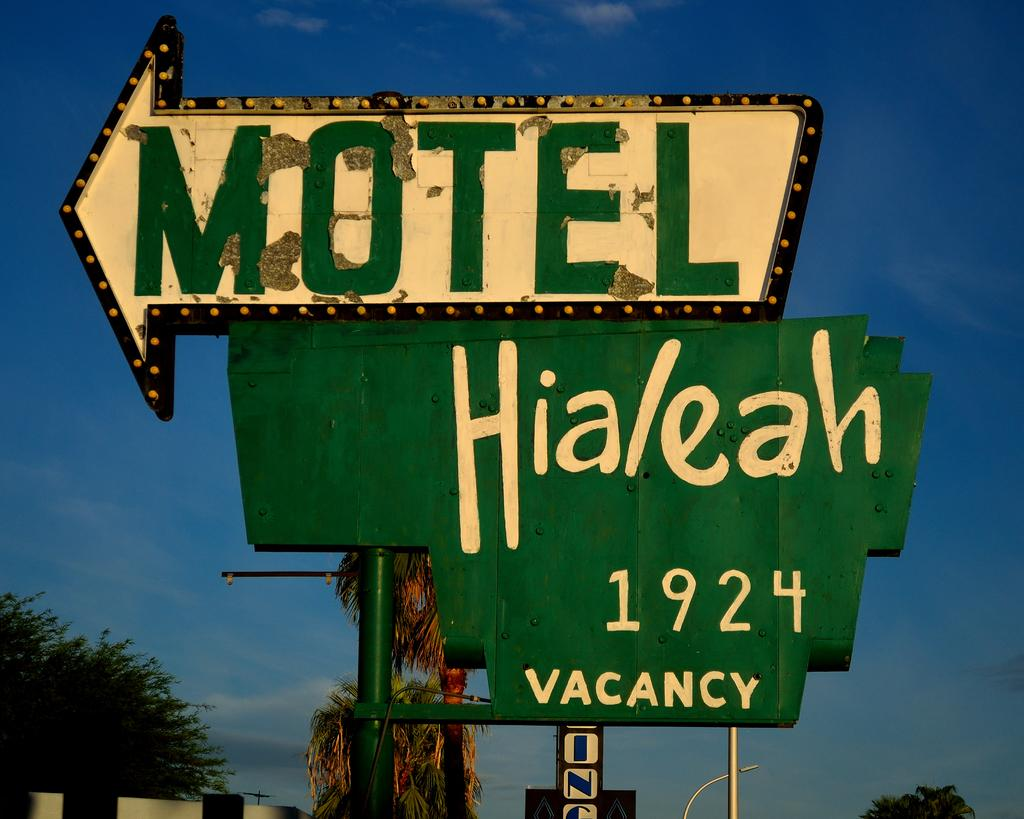What is attached to the poles in the image? Boards are attached to a pole in the image. What type of natural environment can be seen in the image? Trees are visible in the image. How many poles are present in the image? There are poles in the image. What is the color of the sky in the image? The sky is blue in the image. What type of rhythm can be heard coming from the trees in the image? There is no sound, including rhythm, present in the image. Is there any smoke visible in the image? There is no smoke present in the image. 